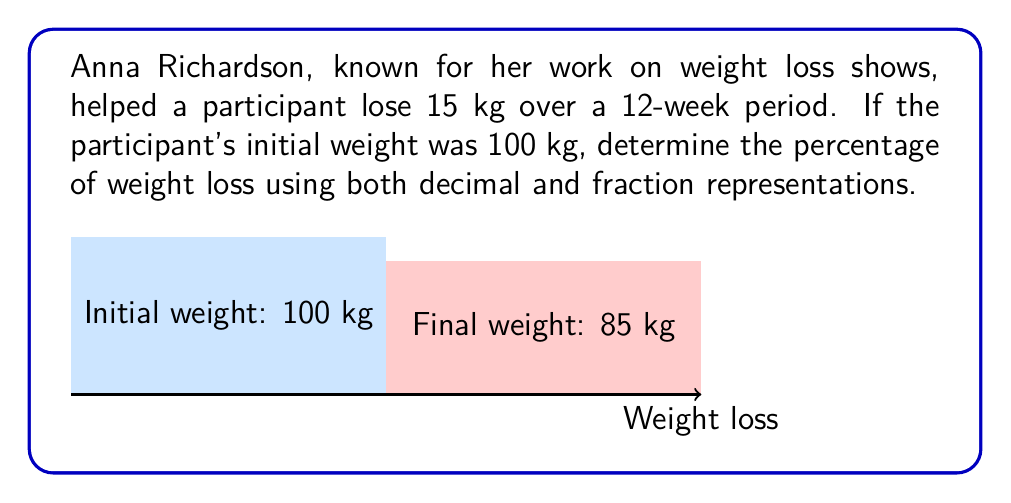Teach me how to tackle this problem. Let's approach this step-by-step:

1) Initial weight = 100 kg
   Weight loss = 15 kg
   Final weight = 100 kg - 15 kg = 85 kg

2) To calculate the percentage of weight loss, we use the formula:
   $$ \text{Percentage loss} = \frac{\text{Weight loss}}{\text{Initial weight}} \times 100\% $$

3) Substituting our values:
   $$ \text{Percentage loss} = \frac{15 \text{ kg}}{100 \text{ kg}} \times 100\% $$

4) Simplify the fraction:
   $$ \text{Percentage loss} = \frac{15}{100} \times 100\% = 0.15 \times 100\% $$

5) Calculate the final percentage:
   $$ \text{Percentage loss} = 15\% $$

6) For the decimal representation, we can express this as:
   $$ 0.15 $$

7) For the fraction representation, we can express this as:
   $$ \frac{15}{100} $$
   which can be simplified to:
   $$ \frac{3}{20} $$

Therefore, the weight loss can be represented as 15% (percentage), 0.15 (decimal), or 3/20 (fraction).
Answer: 15%, 0.15, or 3/20 